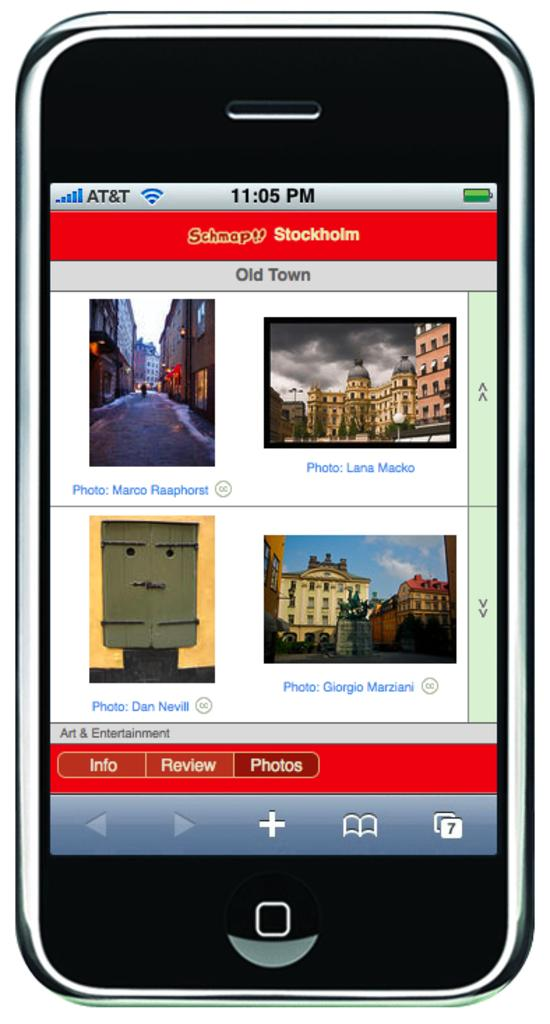<image>
Create a compact narrative representing the image presented. A smart phone displays various photographs of Stockholm, Sweden. 